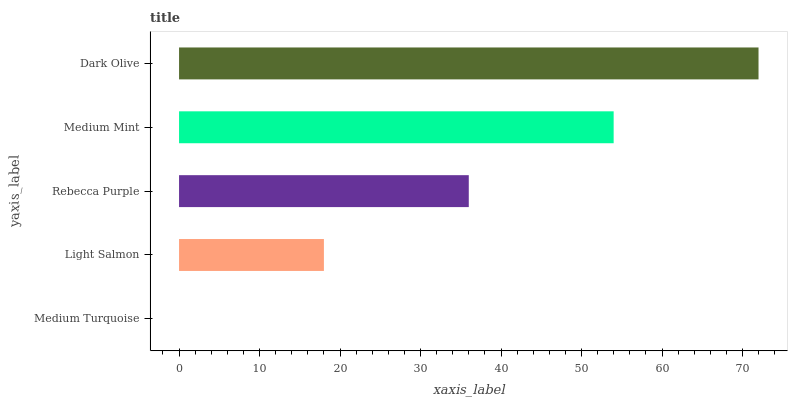Is Medium Turquoise the minimum?
Answer yes or no. Yes. Is Dark Olive the maximum?
Answer yes or no. Yes. Is Light Salmon the minimum?
Answer yes or no. No. Is Light Salmon the maximum?
Answer yes or no. No. Is Light Salmon greater than Medium Turquoise?
Answer yes or no. Yes. Is Medium Turquoise less than Light Salmon?
Answer yes or no. Yes. Is Medium Turquoise greater than Light Salmon?
Answer yes or no. No. Is Light Salmon less than Medium Turquoise?
Answer yes or no. No. Is Rebecca Purple the high median?
Answer yes or no. Yes. Is Rebecca Purple the low median?
Answer yes or no. Yes. Is Light Salmon the high median?
Answer yes or no. No. Is Light Salmon the low median?
Answer yes or no. No. 